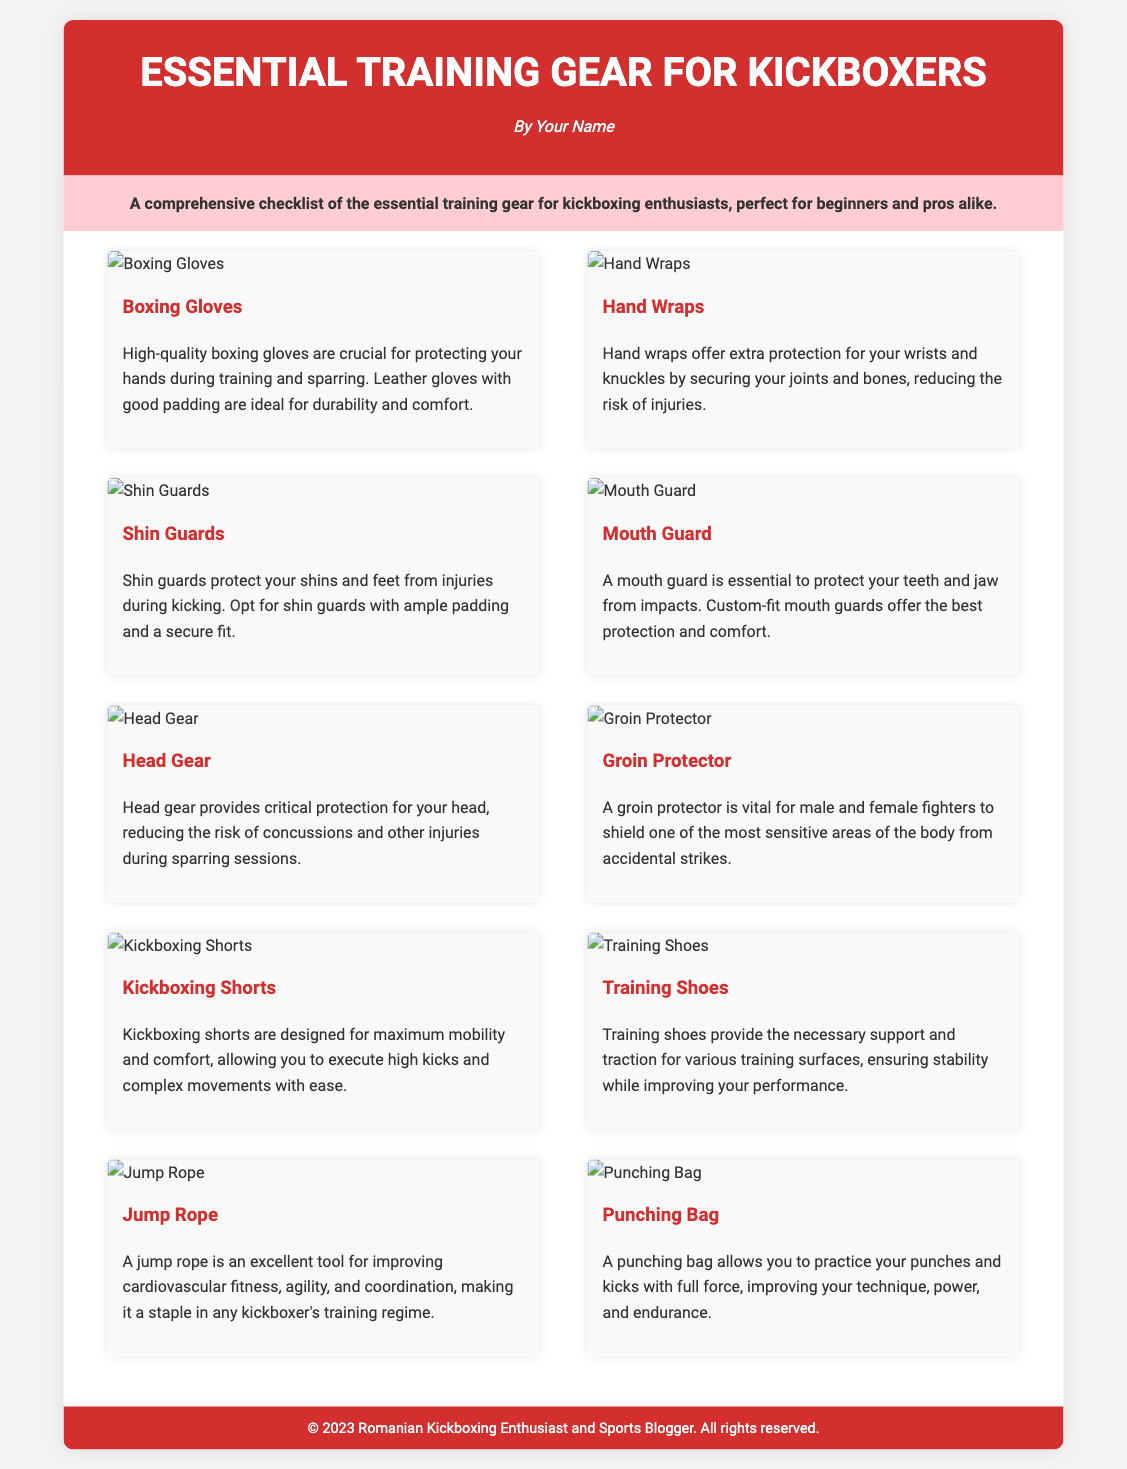What is the title of the document? The title is prominently displayed at the top of the document, which is "Essential Training Gear for Kickboxers."
Answer: Essential Training Gear for Kickboxers How many items are listed in the gear checklist? The document contains a section titled "gear-list" that features ten different items for kickboxing training.
Answer: 10 What color is the header background? The header's background color is specified in the style section of the document, which is a deep red color (#d32f2f).
Answer: Red What protective gear is mentioned for the mouth? The document includes a specific section that highlights the importance of using a protective device for the teeth and jaw referred to as a mouth guard.
Answer: Mouth Guard Which item is recommended for improving agility? According to the document, a jump rope is featured as an excellent tool specifically designed to enhance cardiovascular fitness, agility, and coordination.
Answer: Jump Rope Which gear is essential for hand protection? The document emphasizes that boxing gloves are crucial for protecting the hands during training and sparring.
Answer: Boxing Gloves What is the primary function of shin guards? The description for shin guards states that their primary function is to protect the shins and feet from injuries during kicking.
Answer: Protect shins and feet What is a necessary item for head protection during sparring? The document clearly mentions that head gear is necessary to provide critical protection for the head while sparring.
Answer: Head Gear Which item is designed for maximum mobility during kicks? The section on kickboxing shorts highlights their design aimed at enabling maximum mobility and comfort during high kicks.
Answer: Kickboxing Shorts 